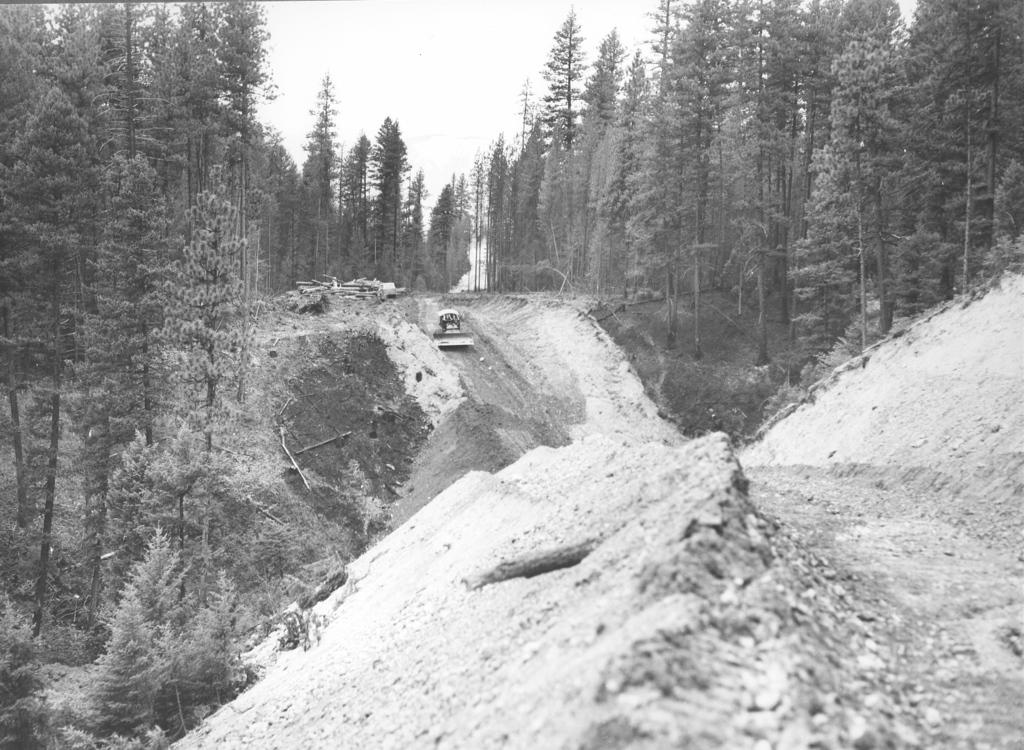What type of landscape feature is present in the image? There is a hill in the image. What can be seen on the hill? There is a truck on the hill. What type of vegetation is present in the image? There are trees in the image. What is visible in the background of the image? The sky is visible in the image. What type of butter is being used to grease the rock in the image? There is no butter or rock present in the image. 